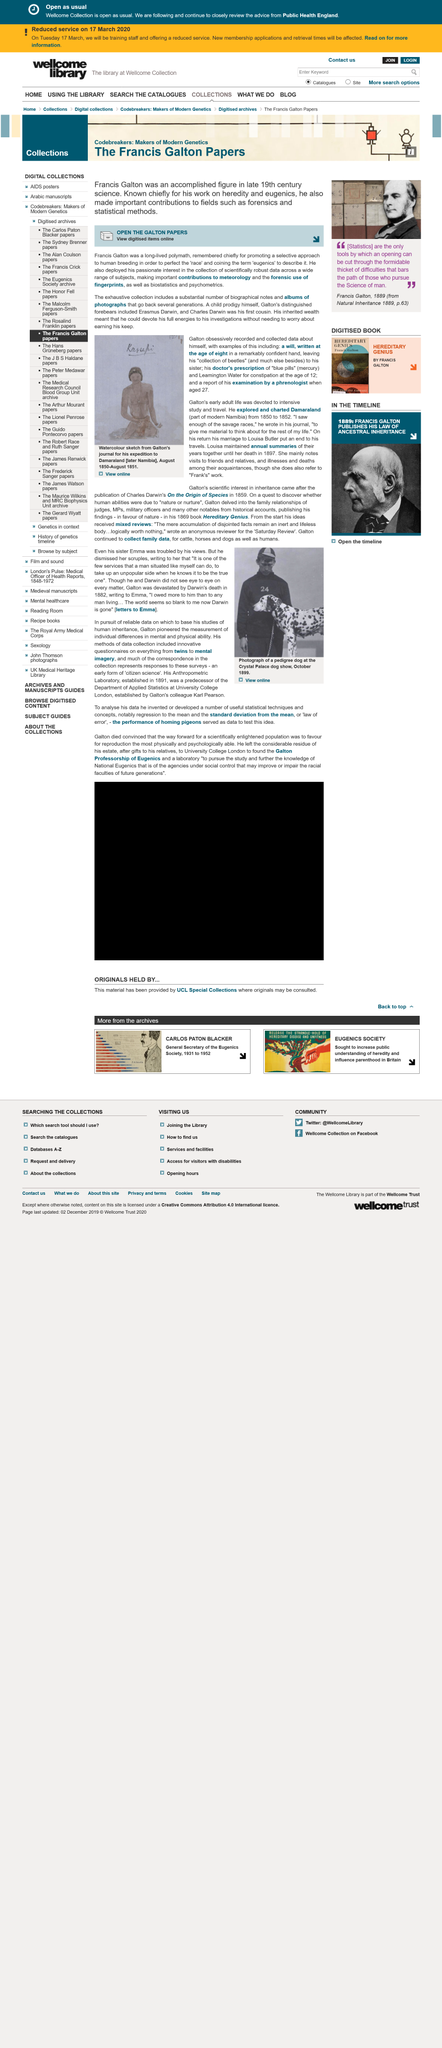Point out several critical features in this image. Francis Galton, a renowned polymath who lived for a considerable period, is primarily remembered for advocating for selective breeding of humans through a narrow and discriminatory approach. In the year 1850, the explorer Francis Galton embarked on an expedition to Damaraland, a region that is currently located within the borders of Namibia. During his journey, which lasted from 1850 to 1852, Galton explored and chartered the land, documenting his findings and observations. This marked the first time that Damaraland had been extensively explored and mapped by a Westerner. Galton's recorded and collected data about himself, including a will, doctor's prescriptions of "blue pills," and a report of his examination by a phrenologist when he was 27, provide insight into his interests and personal habits. The Anthropometric Laboratory was established in 1891 by him. Francis Galton, an accomplished figure in late 19th century science, is renowned for his pioneering work on heredity and eugenics. 